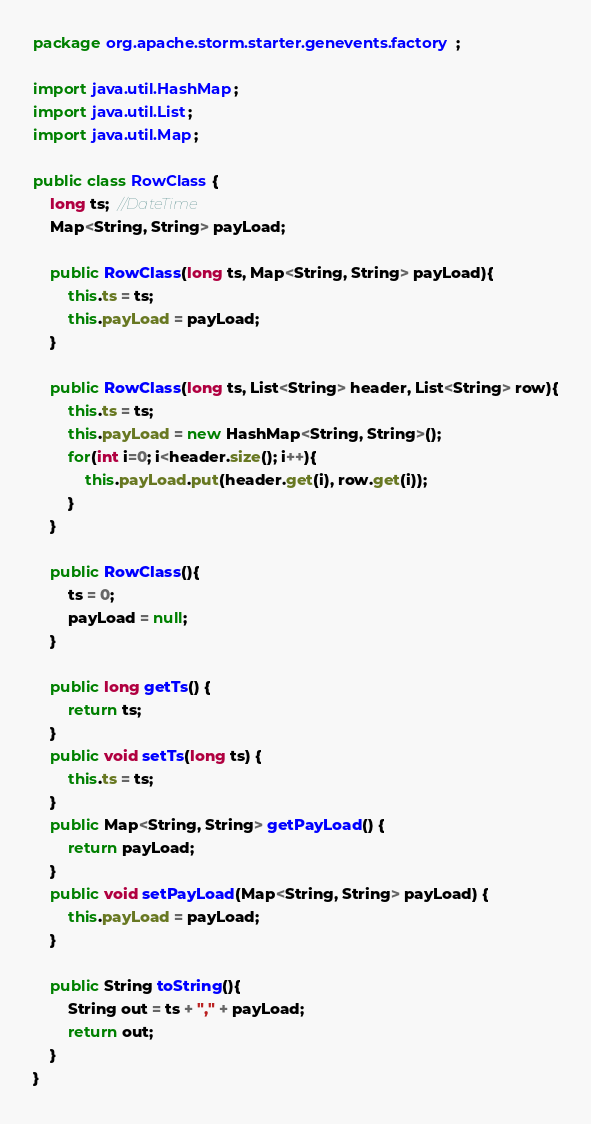<code> <loc_0><loc_0><loc_500><loc_500><_Java_>package org.apache.storm.starter.genevents.factory;

import java.util.HashMap;
import java.util.List;
import java.util.Map;

public class RowClass {
	long ts;  //DateTime
	Map<String, String> payLoad;
	
	public RowClass(long ts, Map<String, String> payLoad){
		this.ts = ts;
		this.payLoad = payLoad;
	}
	
	public RowClass(long ts, List<String> header, List<String> row){
		this.ts = ts;
		this.payLoad = new HashMap<String, String>();
		for(int i=0; i<header.size(); i++){
			this.payLoad.put(header.get(i), row.get(i));
		}
	}
	
	public RowClass(){
		ts = 0;
		payLoad = null;
	}
	
	public long getTs() {
		return ts;
	}
	public void setTs(long ts) {
		this.ts = ts;
	}
	public Map<String, String> getPayLoad() {
		return payLoad;
	}
	public void setPayLoad(Map<String, String> payLoad) {
		this.payLoad = payLoad;
	}
	
	public String toString(){
		String out = ts + "," + payLoad;
		return out;	
	}
}
</code> 